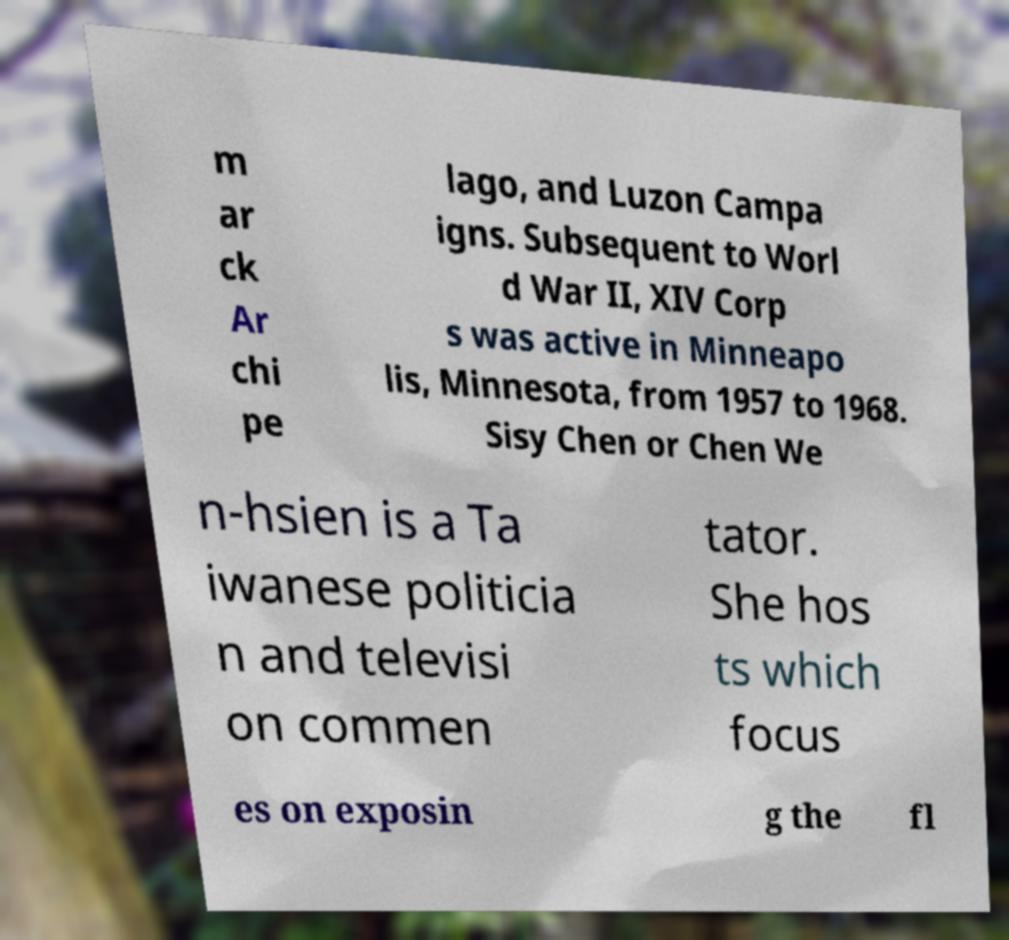For documentation purposes, I need the text within this image transcribed. Could you provide that? m ar ck Ar chi pe lago, and Luzon Campa igns. Subsequent to Worl d War II, XIV Corp s was active in Minneapo lis, Minnesota, from 1957 to 1968. Sisy Chen or Chen We n-hsien is a Ta iwanese politicia n and televisi on commen tator. She hos ts which focus es on exposin g the fl 